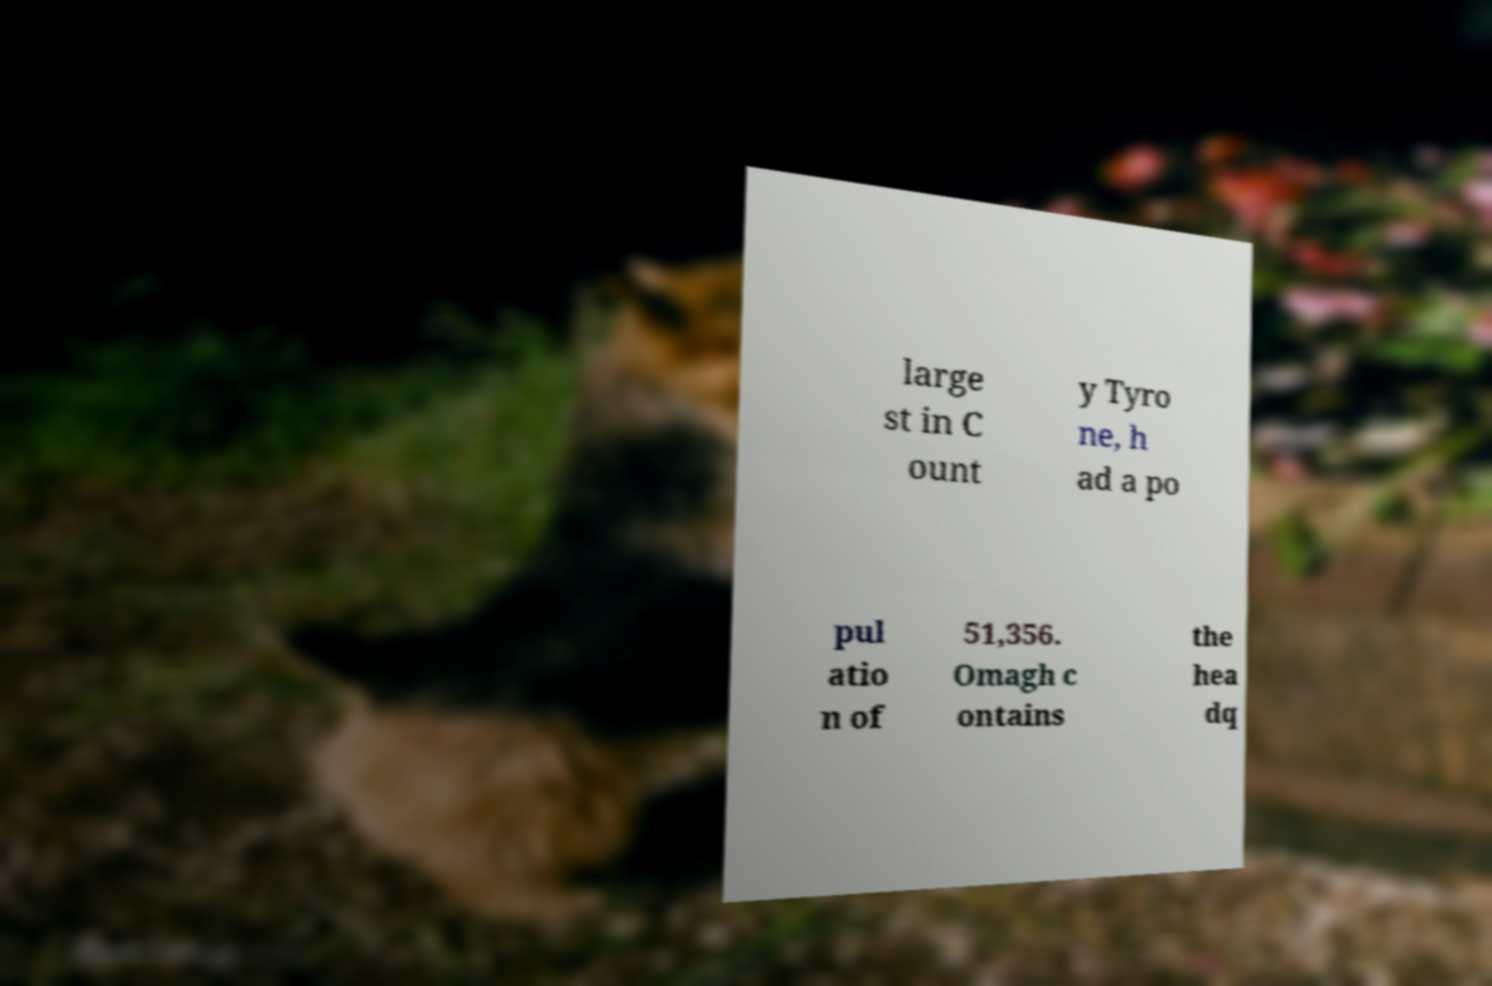Please read and relay the text visible in this image. What does it say? large st in C ount y Tyro ne, h ad a po pul atio n of 51,356. Omagh c ontains the hea dq 